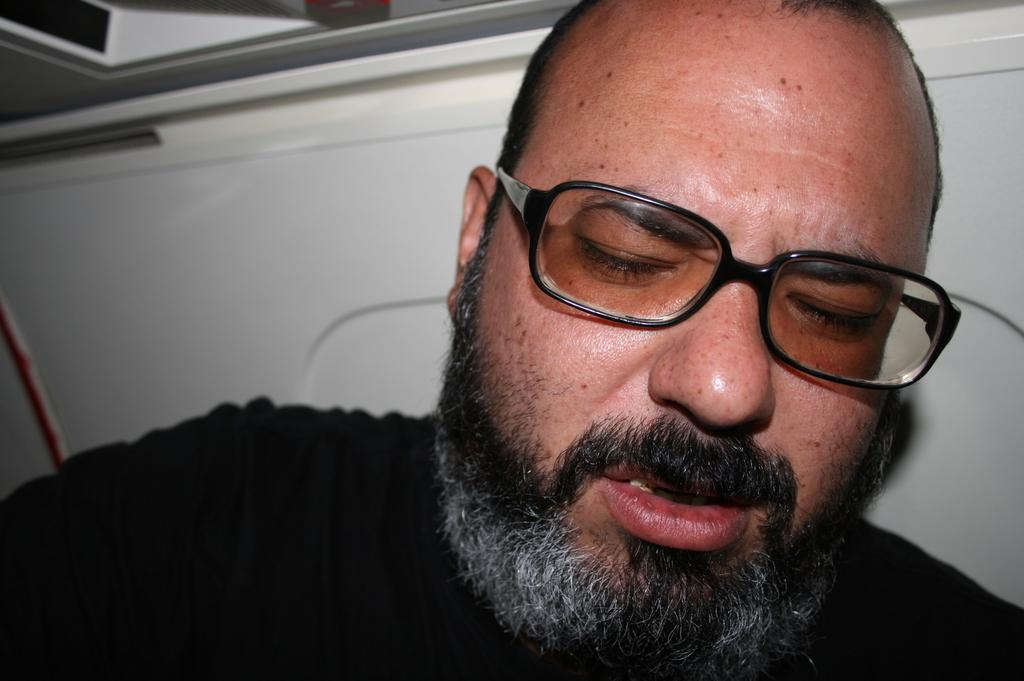Who or what is the main subject in the image? There is a person in the image. What is the person wearing on their upper body? The person is wearing a black T-shirt. Are there any accessories visible on the person? Yes, the person is wearing spectacles. What can be seen behind the person in the image? There is a white wall in the background of the image. What type of mice can be seen running around the person's feet in the image? There are no mice present in the image; the person is standing in front of a white wall. 